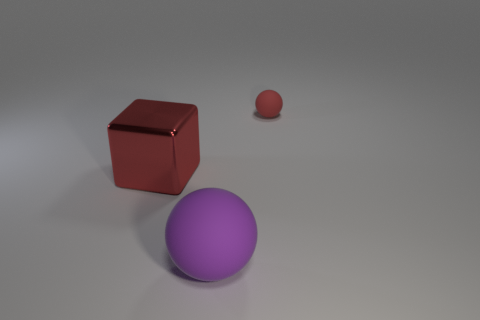Add 1 red rubber spheres. How many objects exist? 4 Subtract all spheres. How many objects are left? 1 Subtract all big purple matte spheres. Subtract all small rubber objects. How many objects are left? 1 Add 2 big red metallic things. How many big red metallic things are left? 3 Add 1 red shiny cubes. How many red shiny cubes exist? 2 Subtract 0 cyan spheres. How many objects are left? 3 